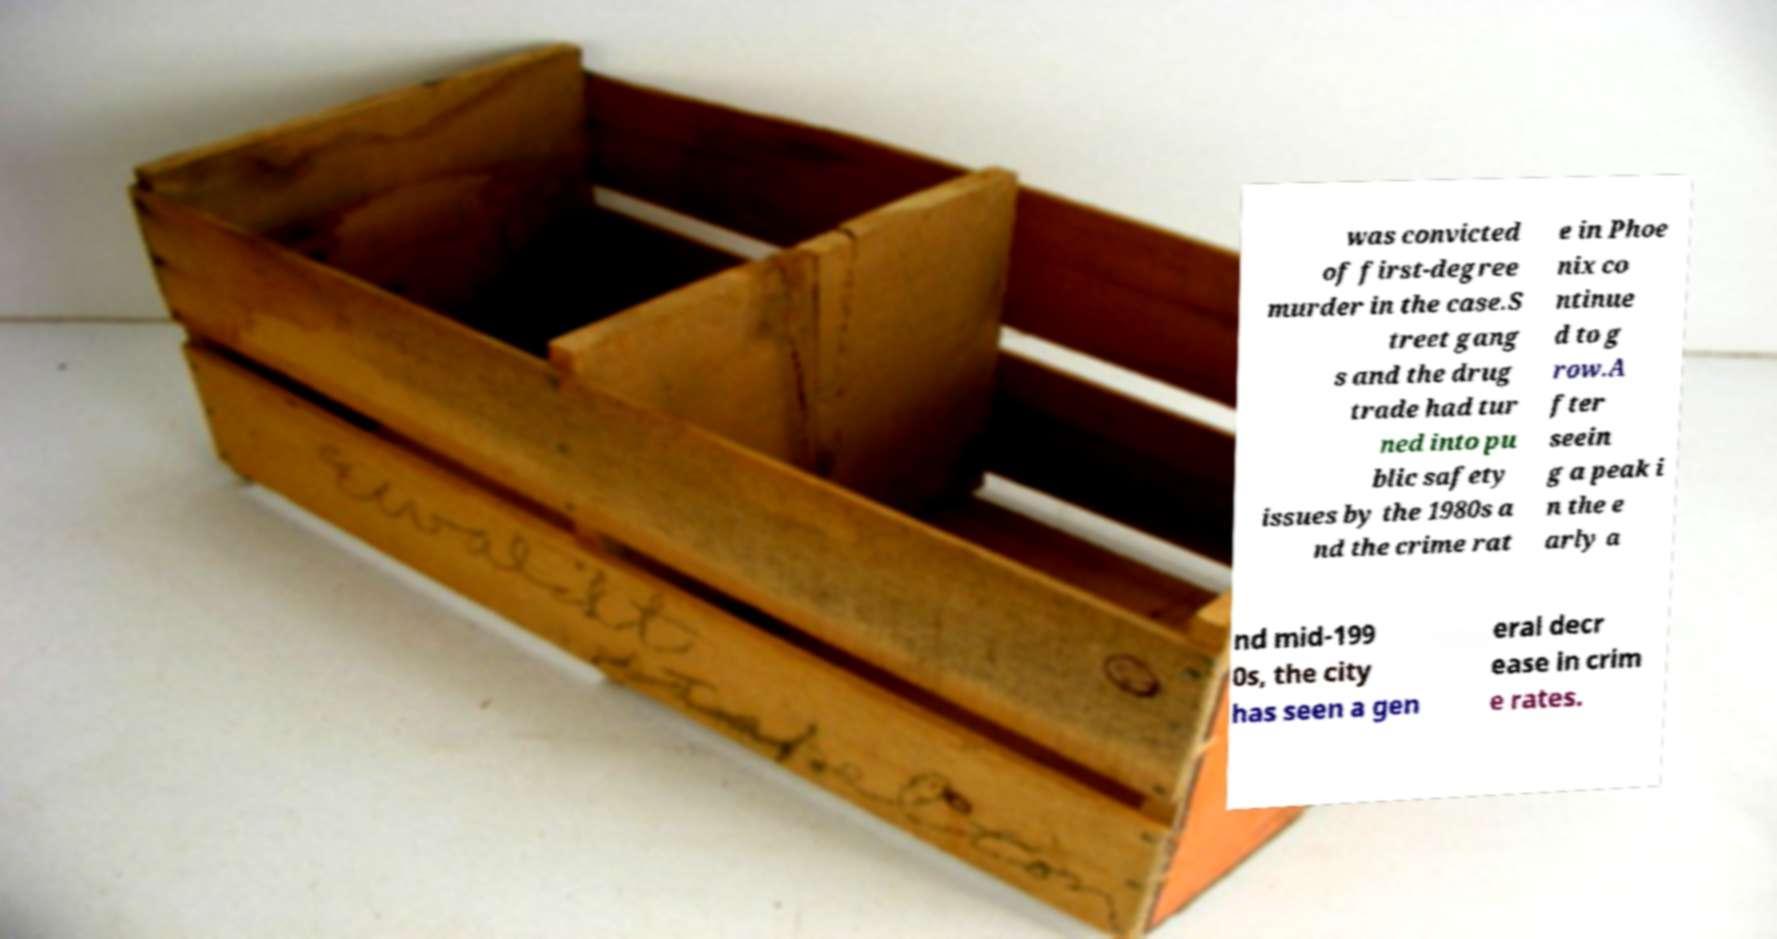For documentation purposes, I need the text within this image transcribed. Could you provide that? was convicted of first-degree murder in the case.S treet gang s and the drug trade had tur ned into pu blic safety issues by the 1980s a nd the crime rat e in Phoe nix co ntinue d to g row.A fter seein g a peak i n the e arly a nd mid-199 0s, the city has seen a gen eral decr ease in crim e rates. 